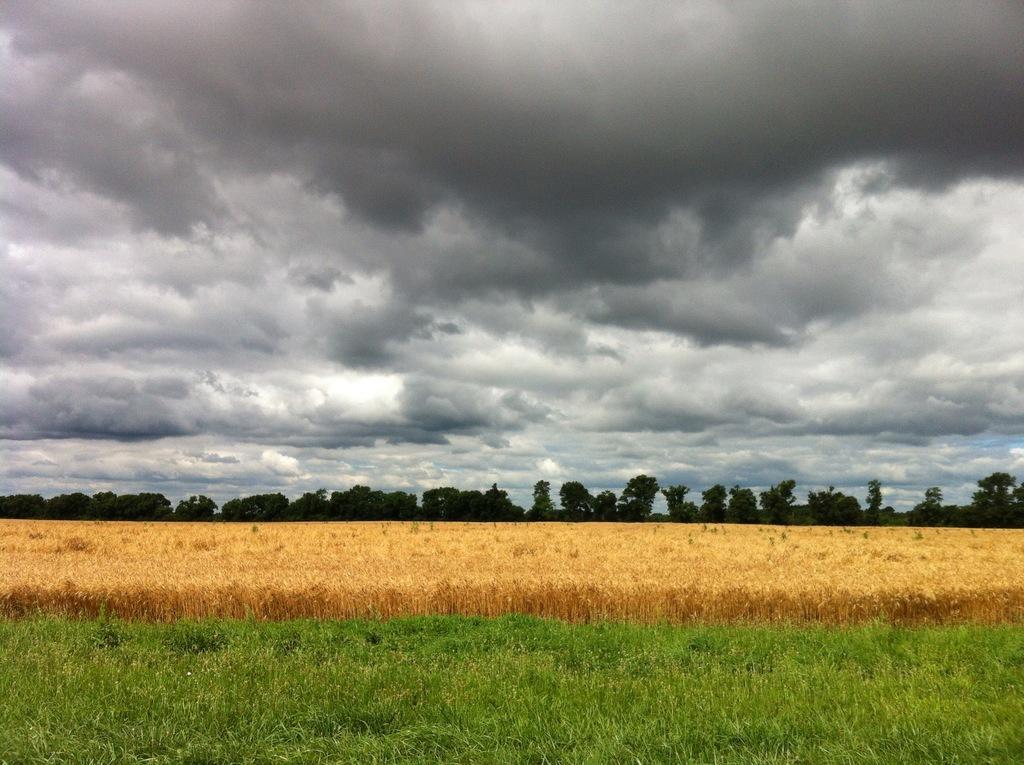Describe this image in one or two sentences. In this image at front there is a grass on the surface. At the background there are trees and sky. 